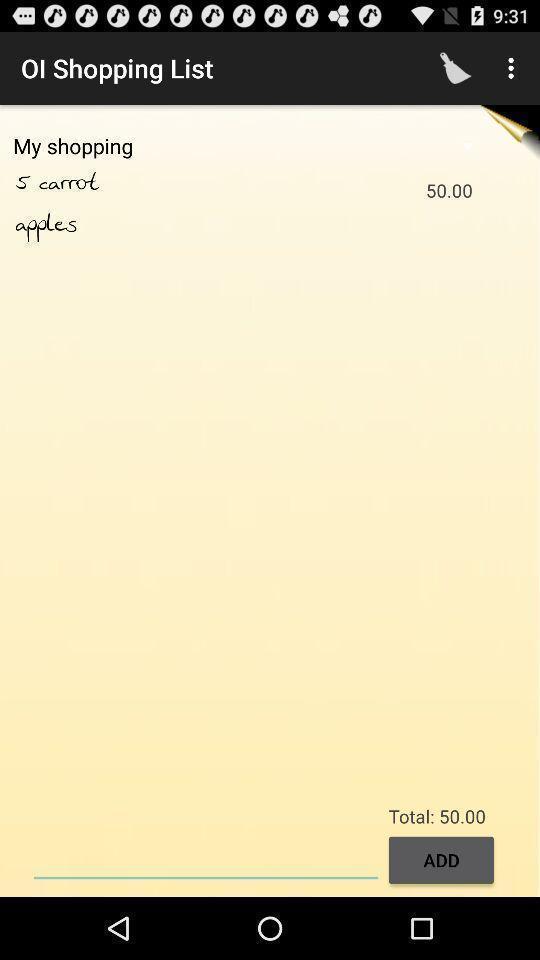Explain the elements present in this screenshot. Page of a shopping list. 